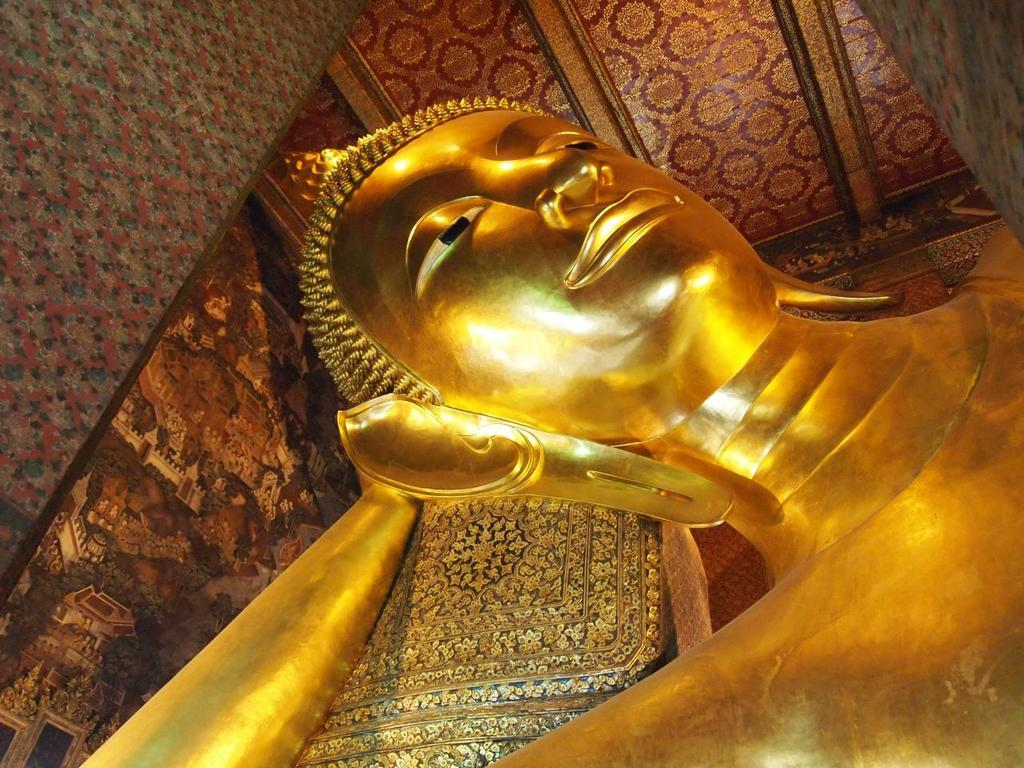What is the main subject of the image? There is a statue of Buddha in the image. Where is the statue located in the image? The statue is in the front of the image. What is visible above the statue in the image? There is a ceiling above the statue in the image. What type of rhythm can be heard coming from the statue in the image? There is no indication of sound or rhythm in the image, as it features a statue of Buddha with a ceiling above it. 